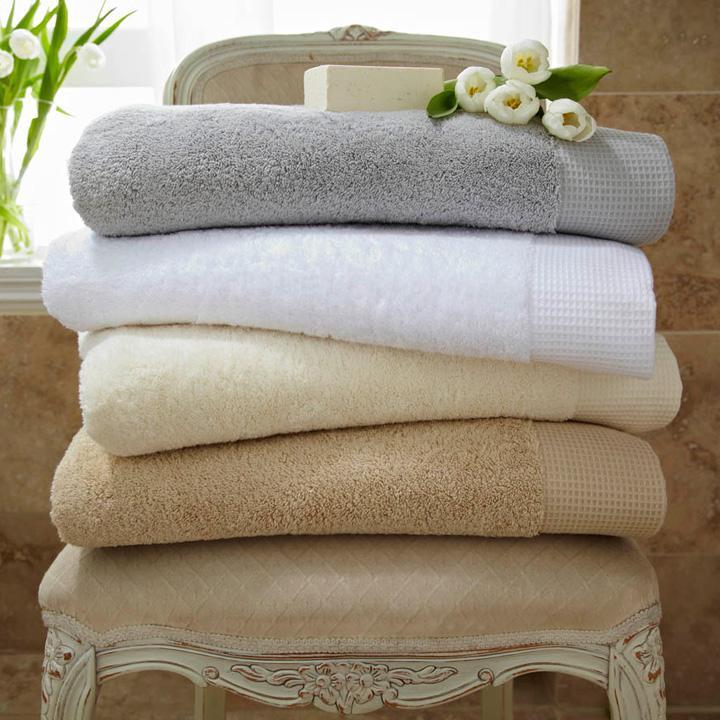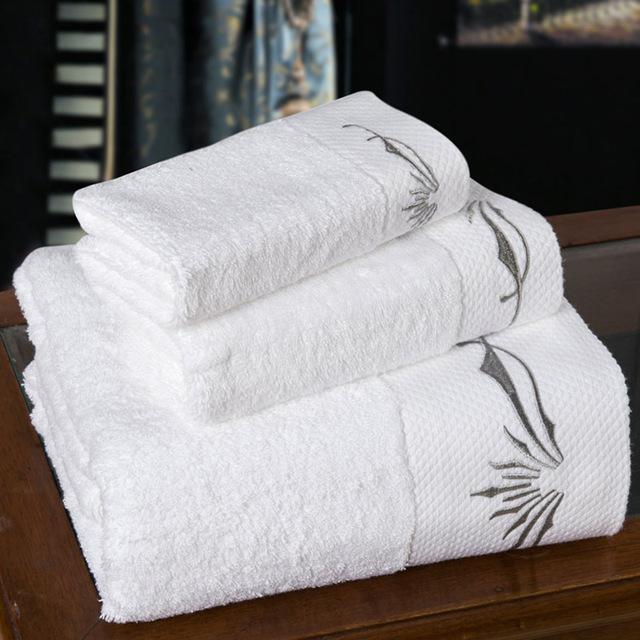The first image is the image on the left, the second image is the image on the right. For the images displayed, is the sentence "All the towels are monogrammed." factually correct? Answer yes or no. No. The first image is the image on the left, the second image is the image on the right. Considering the images on both sides, is "Both images contain a stack of three white towels with embroidery on the bottom." valid? Answer yes or no. No. 